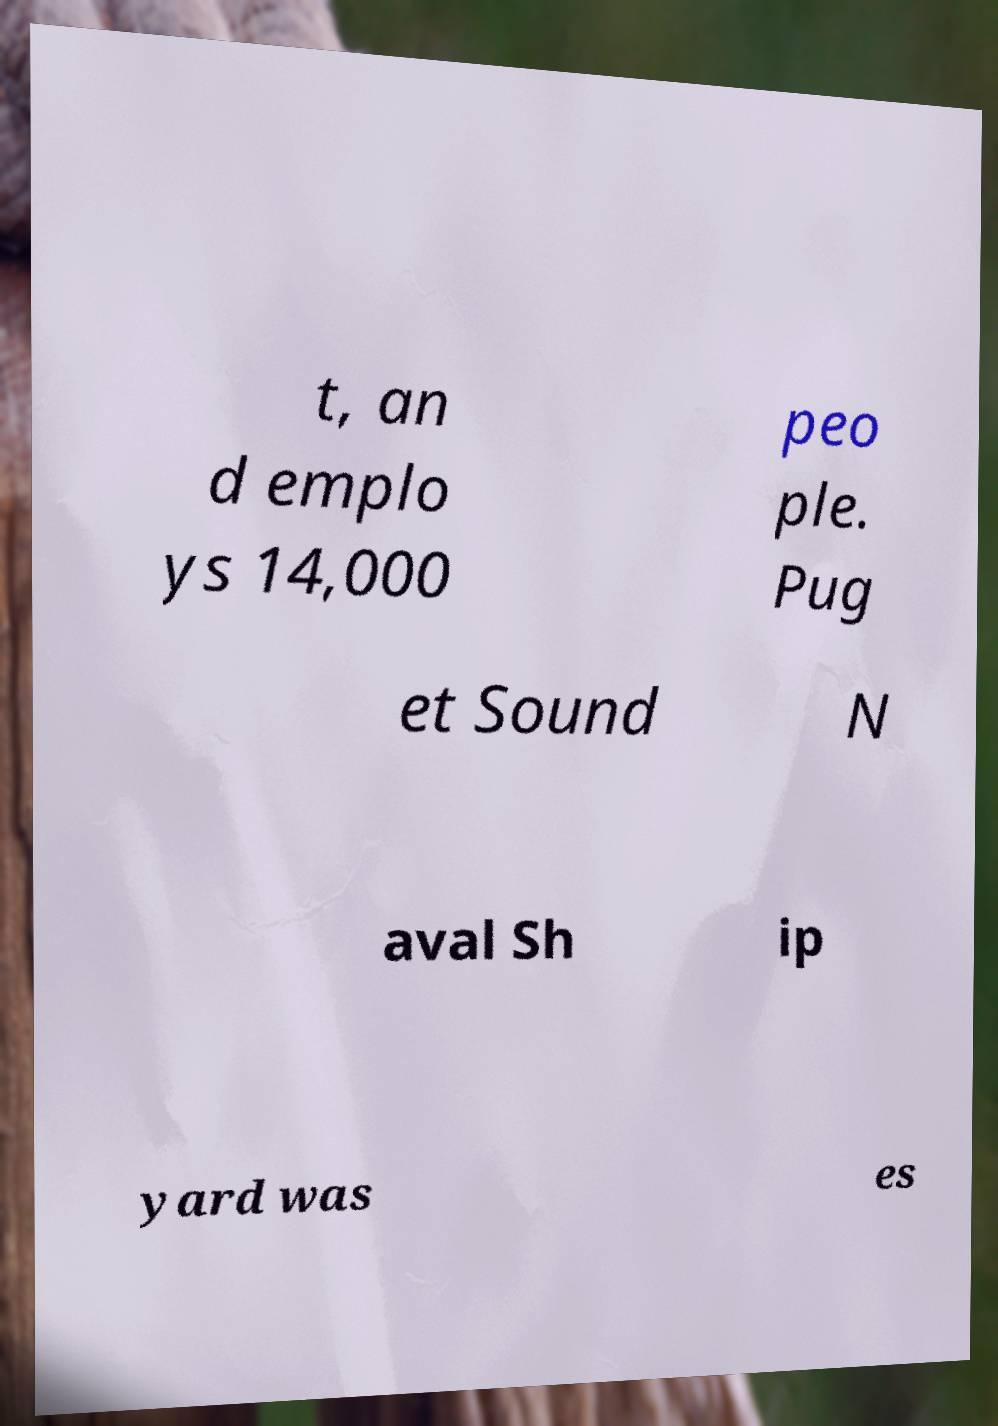Please read and relay the text visible in this image. What does it say? t, an d emplo ys 14,000 peo ple. Pug et Sound N aval Sh ip yard was es 